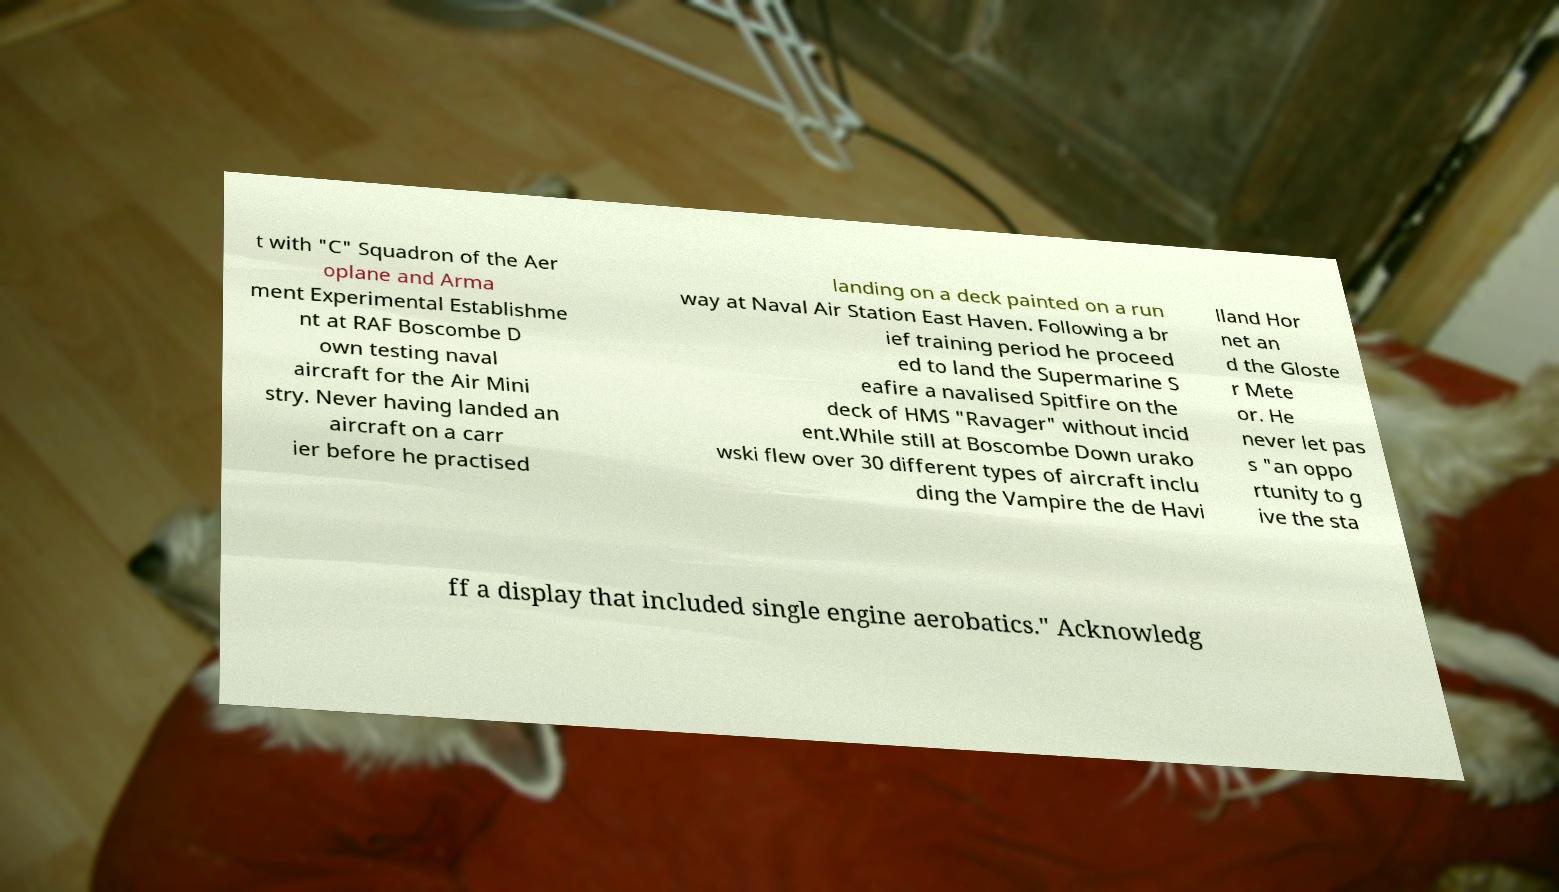Can you accurately transcribe the text from the provided image for me? t with "C" Squadron of the Aer oplane and Arma ment Experimental Establishme nt at RAF Boscombe D own testing naval aircraft for the Air Mini stry. Never having landed an aircraft on a carr ier before he practised landing on a deck painted on a run way at Naval Air Station East Haven. Following a br ief training period he proceed ed to land the Supermarine S eafire a navalised Spitfire on the deck of HMS "Ravager" without incid ent.While still at Boscombe Down urako wski flew over 30 different types of aircraft inclu ding the Vampire the de Havi lland Hor net an d the Gloste r Mete or. He never let pas s "an oppo rtunity to g ive the sta ff a display that included single engine aerobatics." Acknowledg 